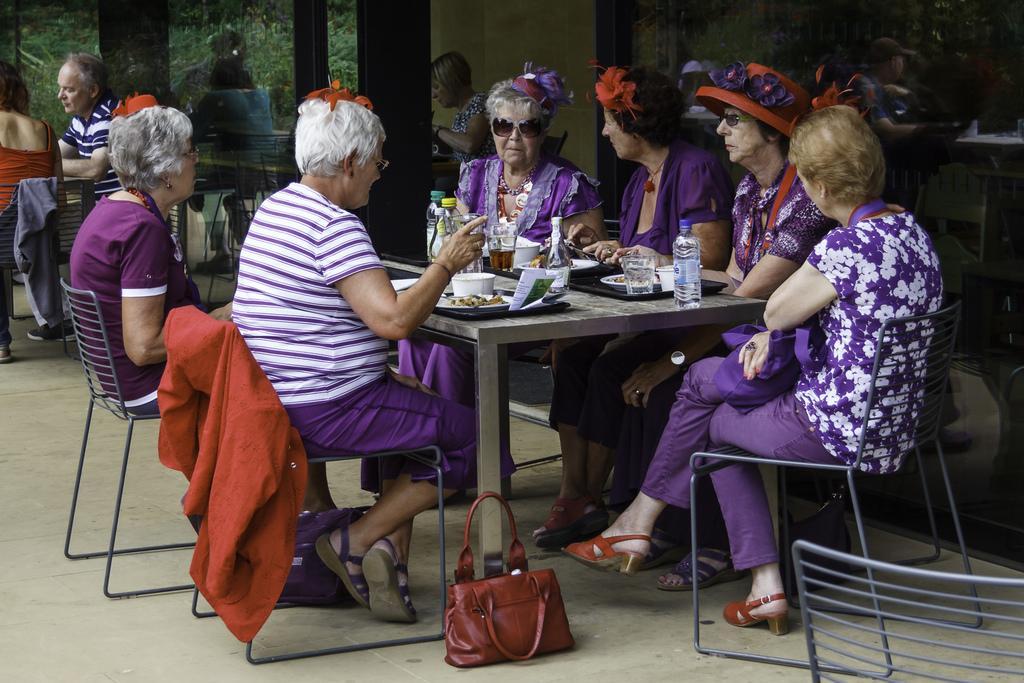How would you summarize this image in a sentence or two? In this image there are group of people sitting chair near the table, and there are cup , plate, glass , bottle in table and the background there is building. 